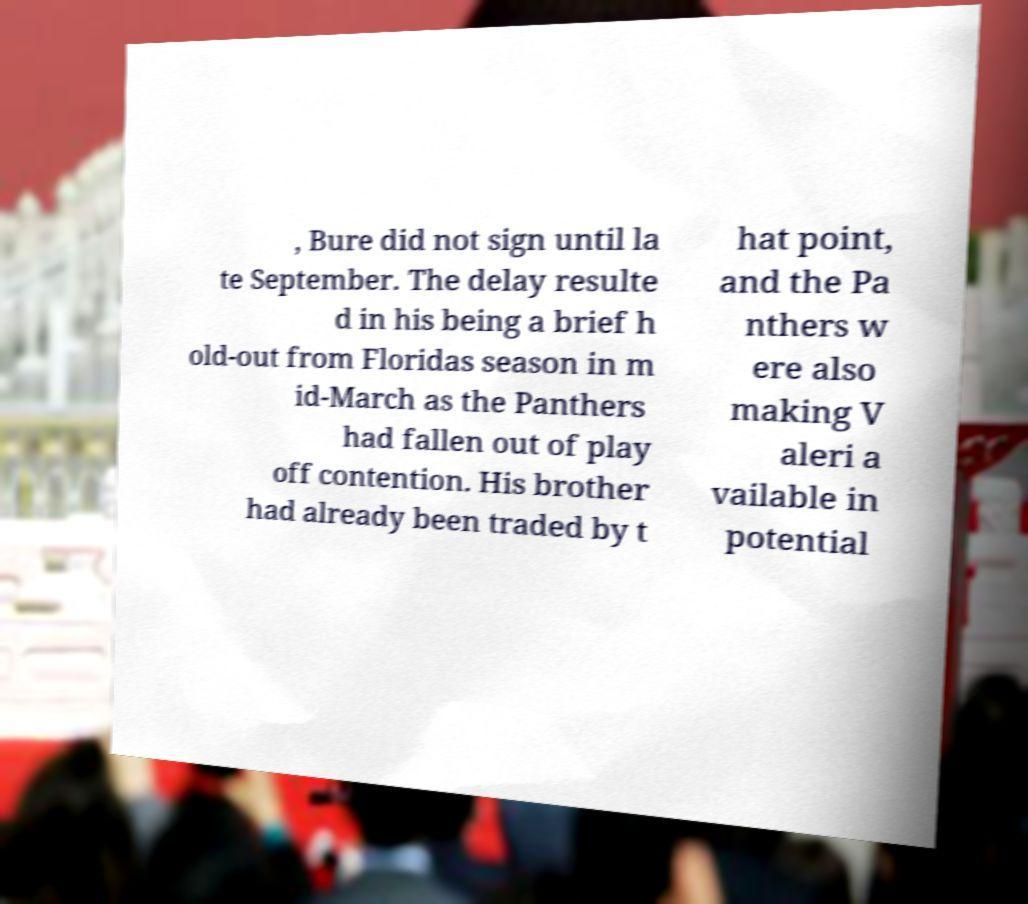For documentation purposes, I need the text within this image transcribed. Could you provide that? , Bure did not sign until la te September. The delay resulte d in his being a brief h old-out from Floridas season in m id-March as the Panthers had fallen out of play off contention. His brother had already been traded by t hat point, and the Pa nthers w ere also making V aleri a vailable in potential 